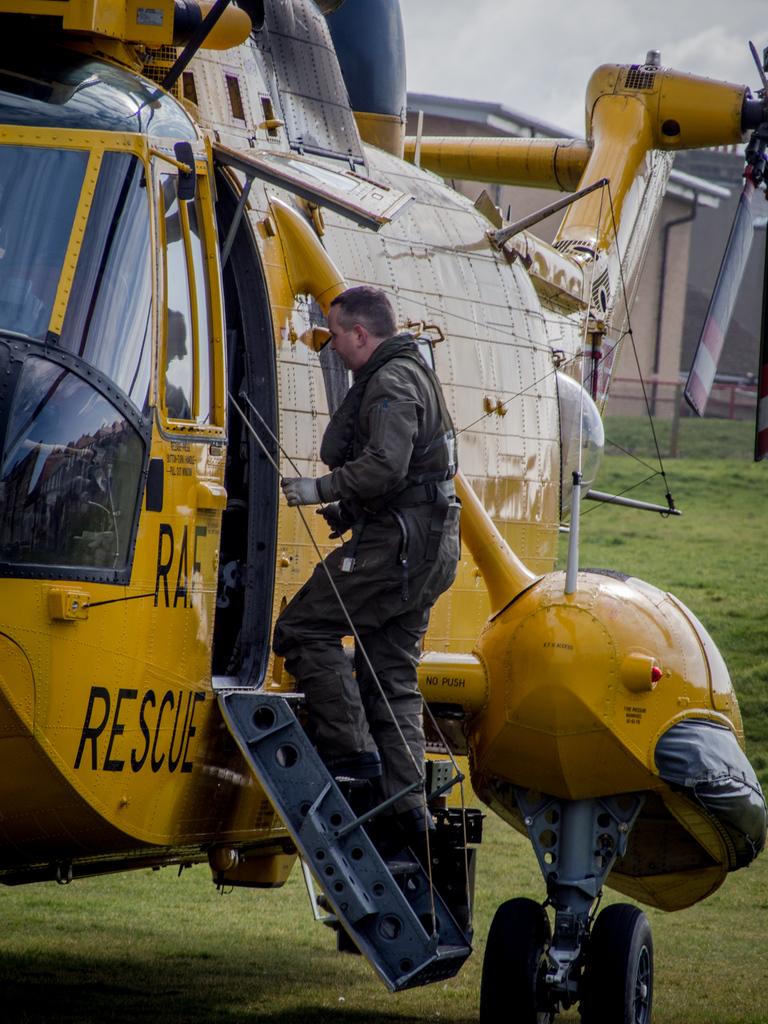What is this plane used for?
Your answer should be compact. Rescue. What are the three letters above rescue?
Make the answer very short. Raf. 